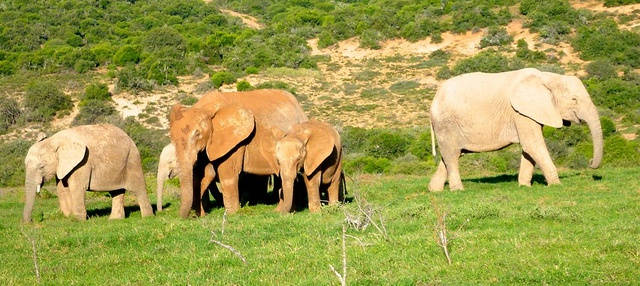Describe the objects in this image and their specific colors. I can see elephant in olive, tan, and beige tones, elephant in olive, orange, tan, and black tones, elephant in olive and tan tones, elephant in olive, tan, and black tones, and elephant in olive, tan, and beige tones in this image. 